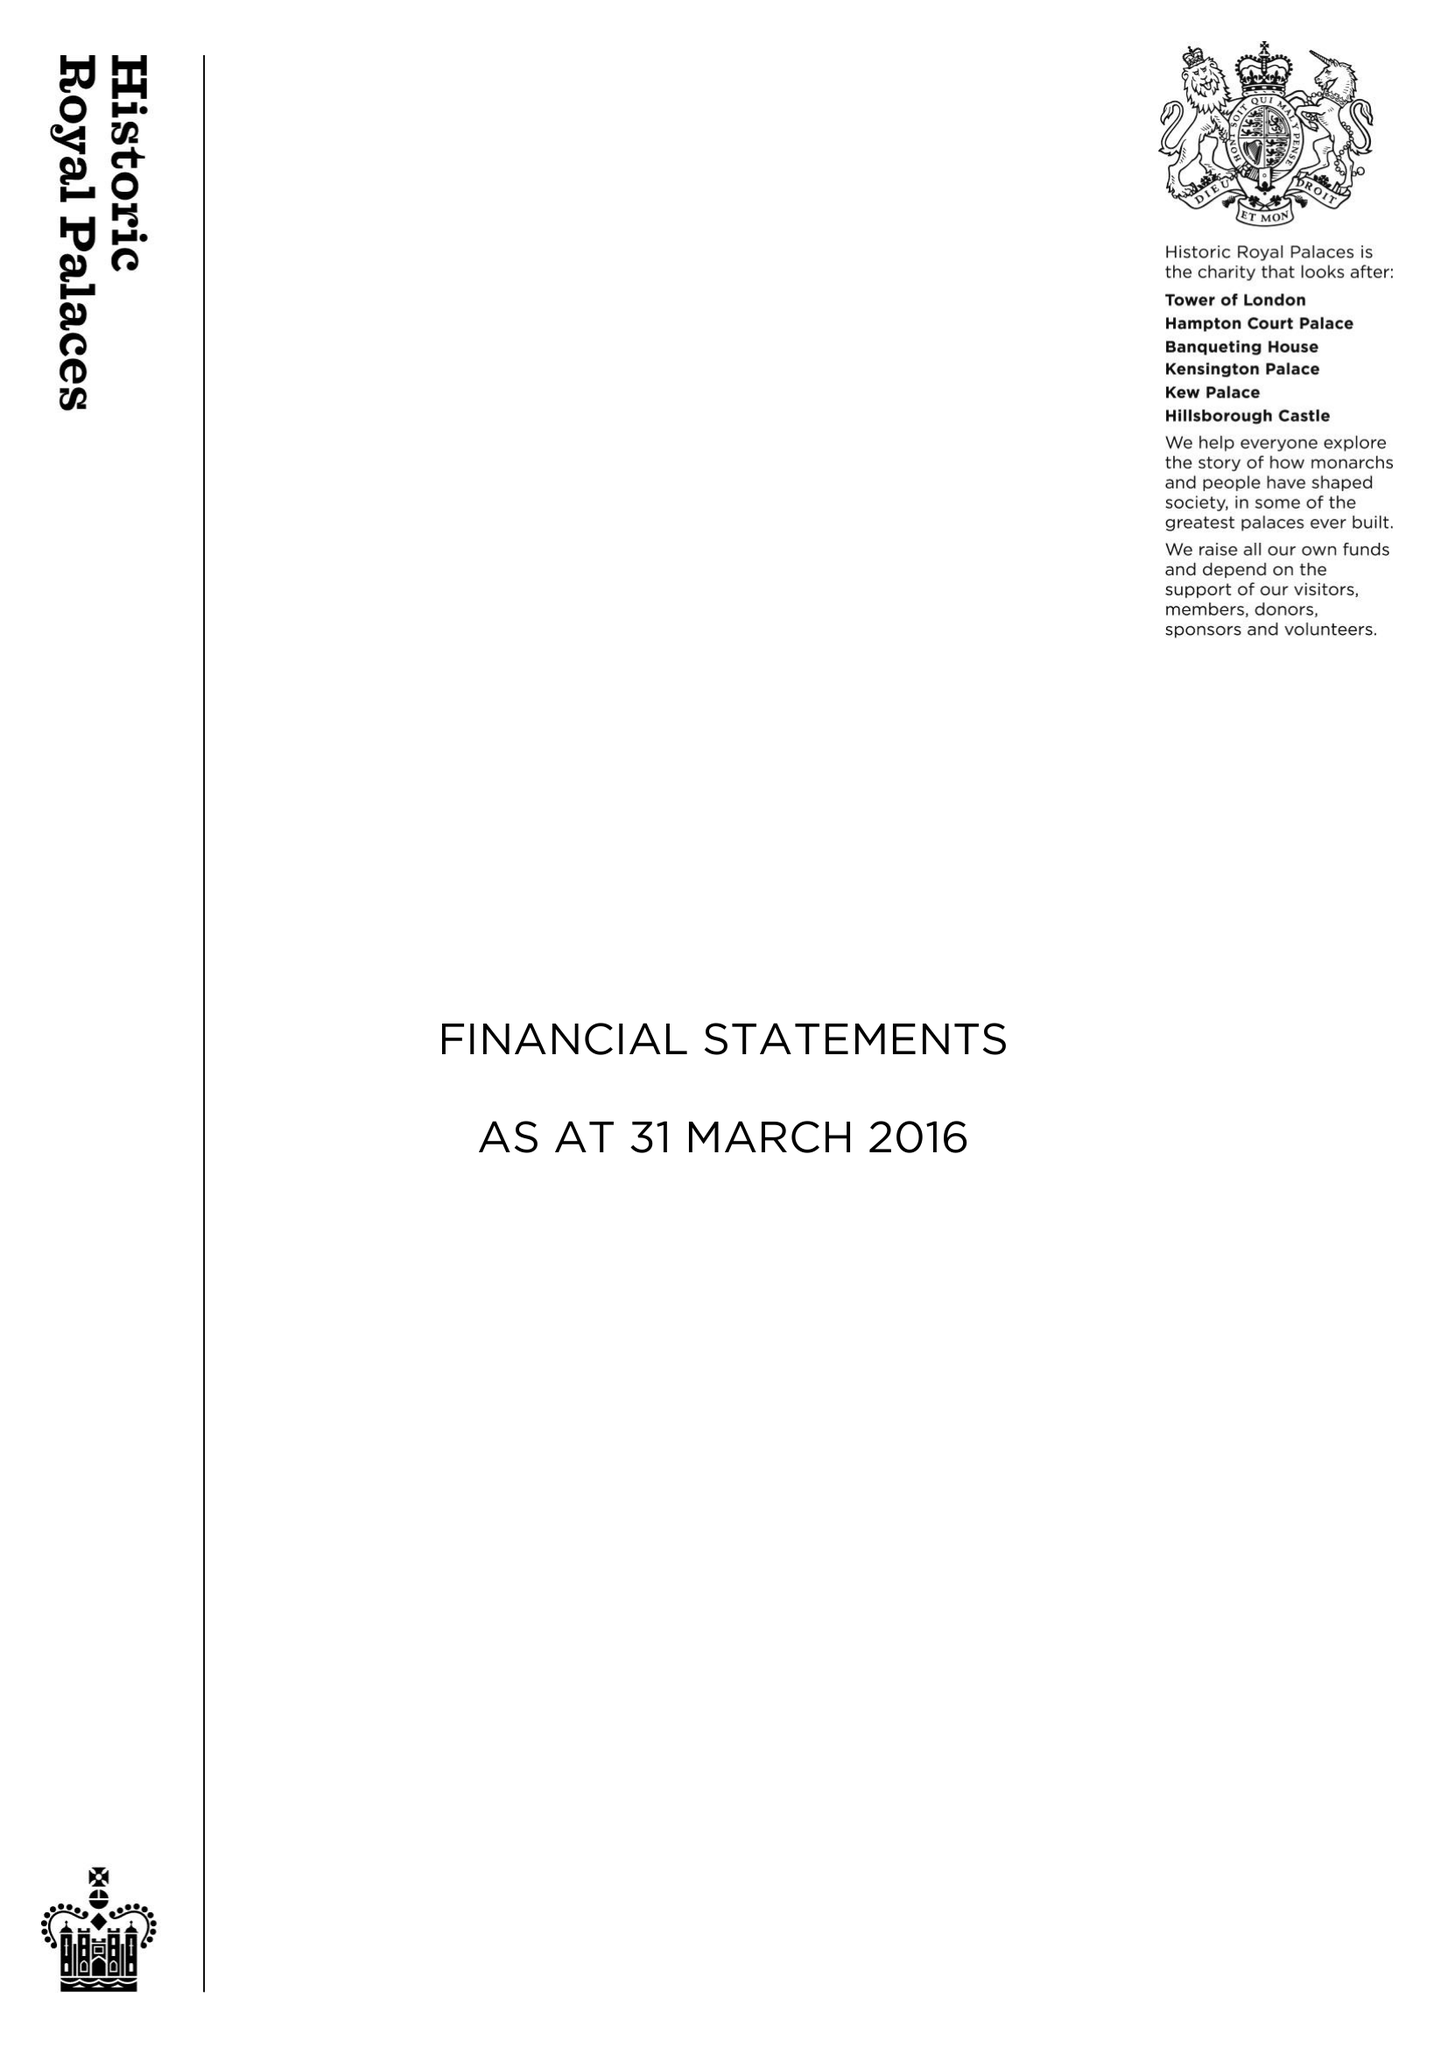What is the value for the report_date?
Answer the question using a single word or phrase. 2016-03-31 